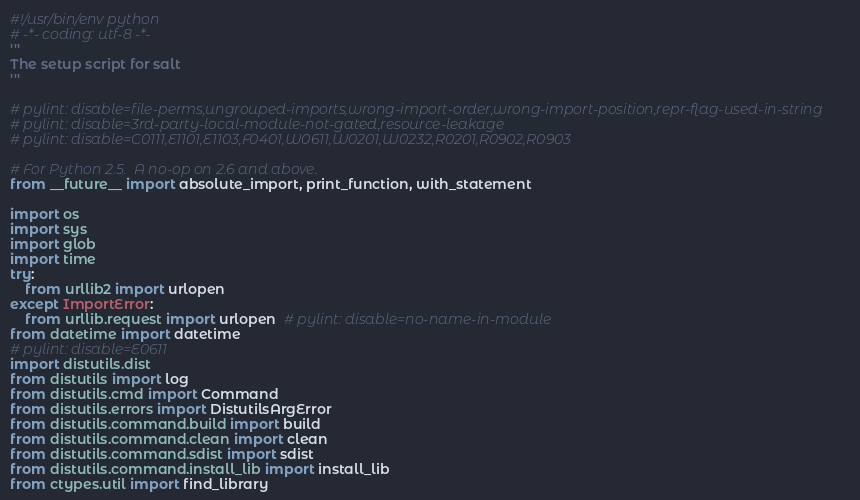Convert code to text. <code><loc_0><loc_0><loc_500><loc_500><_Python_>#!/usr/bin/env python
# -*- coding: utf-8 -*-
'''
The setup script for salt
'''

# pylint: disable=file-perms,ungrouped-imports,wrong-import-order,wrong-import-position,repr-flag-used-in-string
# pylint: disable=3rd-party-local-module-not-gated,resource-leakage
# pylint: disable=C0111,E1101,E1103,F0401,W0611,W0201,W0232,R0201,R0902,R0903

# For Python 2.5.  A no-op on 2.6 and above.
from __future__ import absolute_import, print_function, with_statement

import os
import sys
import glob
import time
try:
    from urllib2 import urlopen
except ImportError:
    from urllib.request import urlopen  # pylint: disable=no-name-in-module
from datetime import datetime
# pylint: disable=E0611
import distutils.dist
from distutils import log
from distutils.cmd import Command
from distutils.errors import DistutilsArgError
from distutils.command.build import build
from distutils.command.clean import clean
from distutils.command.sdist import sdist
from distutils.command.install_lib import install_lib
from ctypes.util import find_library</code> 